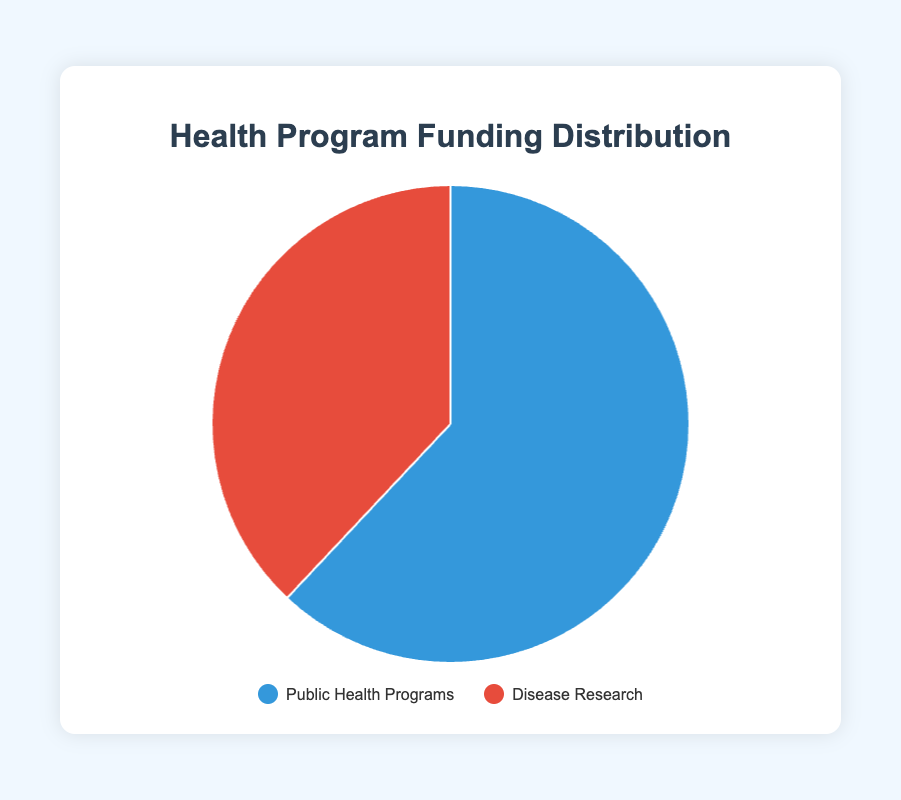What percentage of the total funding is allocated to Public Health Programs? Public Health Programs received $62,000,000 and the total funding is $100,000,000. The percentage is calculated as ($62,000,000 / $100,000,000) * 100 = 62%.
Answer: 62% Which health program category received less funding? Compare $62,000,000 for Public Health Programs to $38,000,000 for Disease Research. Disease Research received less funding.
Answer: Disease Research How much more funding did Public Health Programs receive compared to Disease Research? Public Health Programs received $62,000,000, and Disease Research received $38,000,000. The difference is $62,000,000 - $38,000,000 = $24,000,000.
Answer: $24,000,000 What color represents Disease Research on the pie chart? Based on the legend, Disease Research is represented by the red color.
Answer: Red What is the combined funding amount for Public Health Programs and Disease Research? Public Health Programs received $62,000,000 and Disease Research received $38,000,000. The total is $62,000,000 + $38,000,000 = $100,000,000.
Answer: $100,000,000 By how much did the Public Health Programs funding exceed half of the total funding? Half of the total funding is $100,000,000 / 2 = $50,000,000. Public Health Programs received $62,000,000, exceeding by $62,000,000 - $50,000,000 = $12,000,000.
Answer: $12,000,000 What fraction of the pie chart corresponds to Disease Research? The pie chart represents funding with $100,000,000 total. Disease Research received $38,000,000 which is 38/100 = 19/50 or 0.38 of the pie chart.
Answer: 0.38 Which funding category has a greater visual representation on the pie chart? By comparing the sizes of the segments, the larger segment represents Public Health Programs.
Answer: Public Health Programs What is the sum of the percentages represented by both categories on the pie chart? The funding distribution adds up to the total budget, which means the sum of their percentages must be 100%.
Answer: 100% If another category was added receiving $20,000,000, how would this affect the distribution percentages for the current categories? The new total funding would be $62,000,000 + $38,000,000 + $20,000,000 = $120,000,000. Public Health Programs would be ($62,000,000 / $120,000,000) * 100 ≈ 51.67%, Disease Research would be ($38,000,000 / $120,000,000) * 100 ≈ 31.67%, and the new category would be ($20,000,000 / $120,000,000) * 100 ≈ 16.67%.
Answer: Public Health Programs: 51.67%, Disease Research: 31.67%, New category: 16.67% 